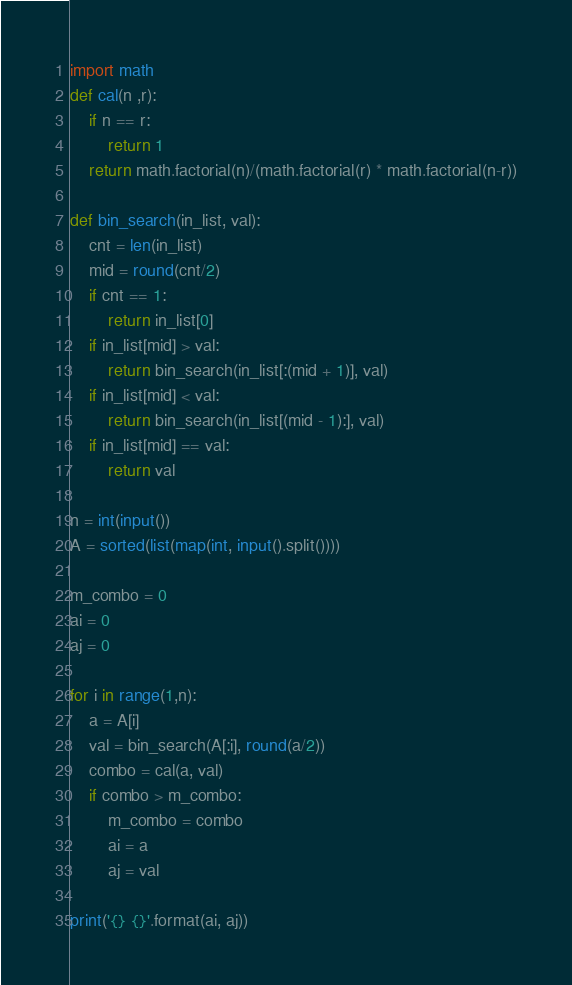<code> <loc_0><loc_0><loc_500><loc_500><_Python_>import math
def cal(n ,r):
    if n == r:
        return 1
    return math.factorial(n)/(math.factorial(r) * math.factorial(n-r))

def bin_search(in_list, val):
    cnt = len(in_list)
    mid = round(cnt/2)
    if cnt == 1:
        return in_list[0]
    if in_list[mid] > val:
        return bin_search(in_list[:(mid + 1)], val)
    if in_list[mid] < val:
        return bin_search(in_list[(mid - 1):], val)
    if in_list[mid] == val:
        return val

n = int(input())
A = sorted(list(map(int, input().split())))

m_combo = 0
ai = 0
aj = 0

for i in range(1,n):
    a = A[i]
    val = bin_search(A[:i], round(a/2))
    combo = cal(a, val)
    if combo > m_combo:
        m_combo = combo
        ai = a
        aj = val

print('{} {}'.format(ai, aj))
</code> 